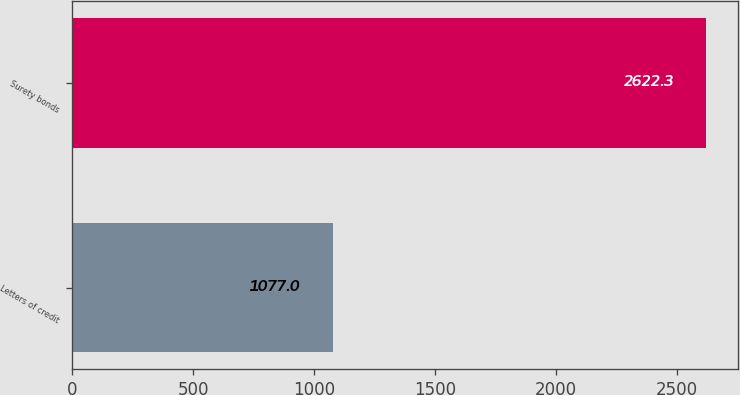<chart> <loc_0><loc_0><loc_500><loc_500><bar_chart><fcel>Letters of credit<fcel>Surety bonds<nl><fcel>1077<fcel>2622.3<nl></chart> 